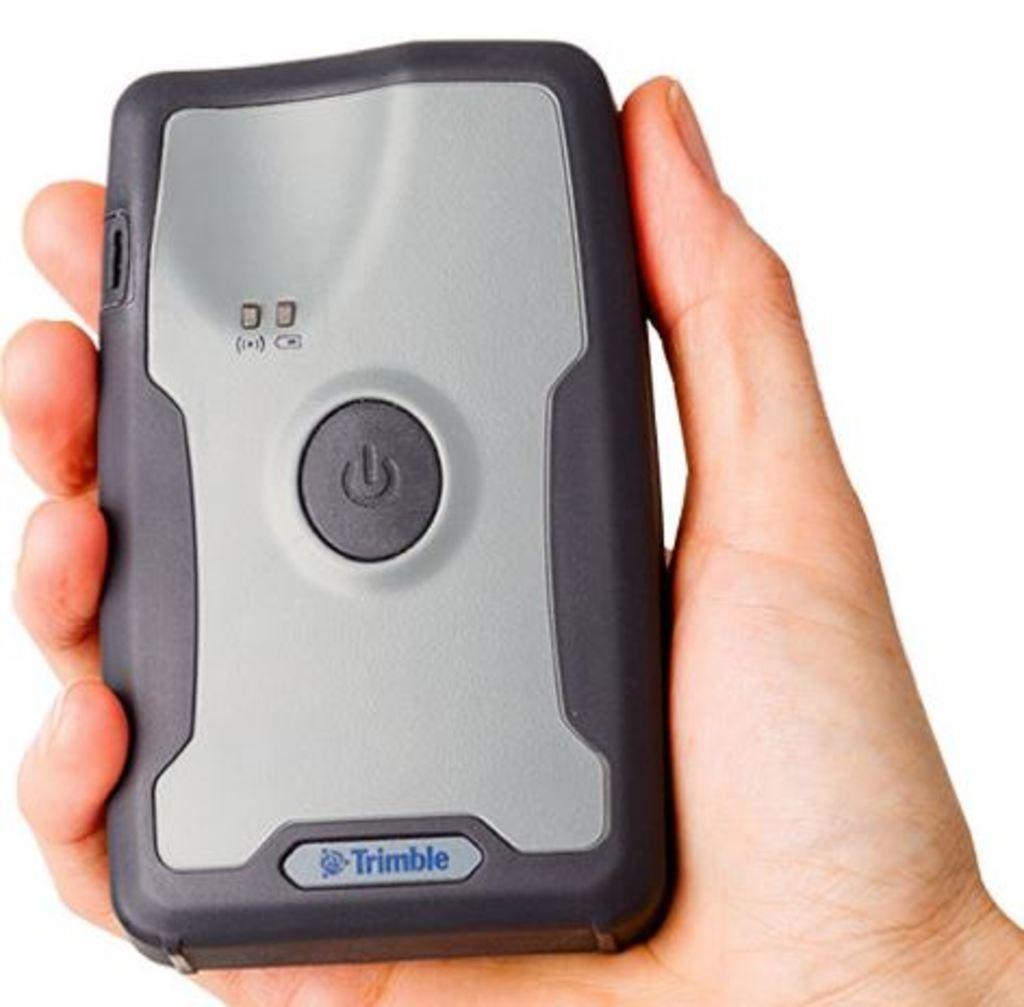Could you give a brief overview of what you see in this image? In the picture I can see an electronic gadget in a person's hand. The background of the image is white in color. 